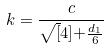Convert formula to latex. <formula><loc_0><loc_0><loc_500><loc_500>k = \frac { c } { \sqrt { [ } 4 ] { + \frac { d _ { 1 } } { 6 } } }</formula> 